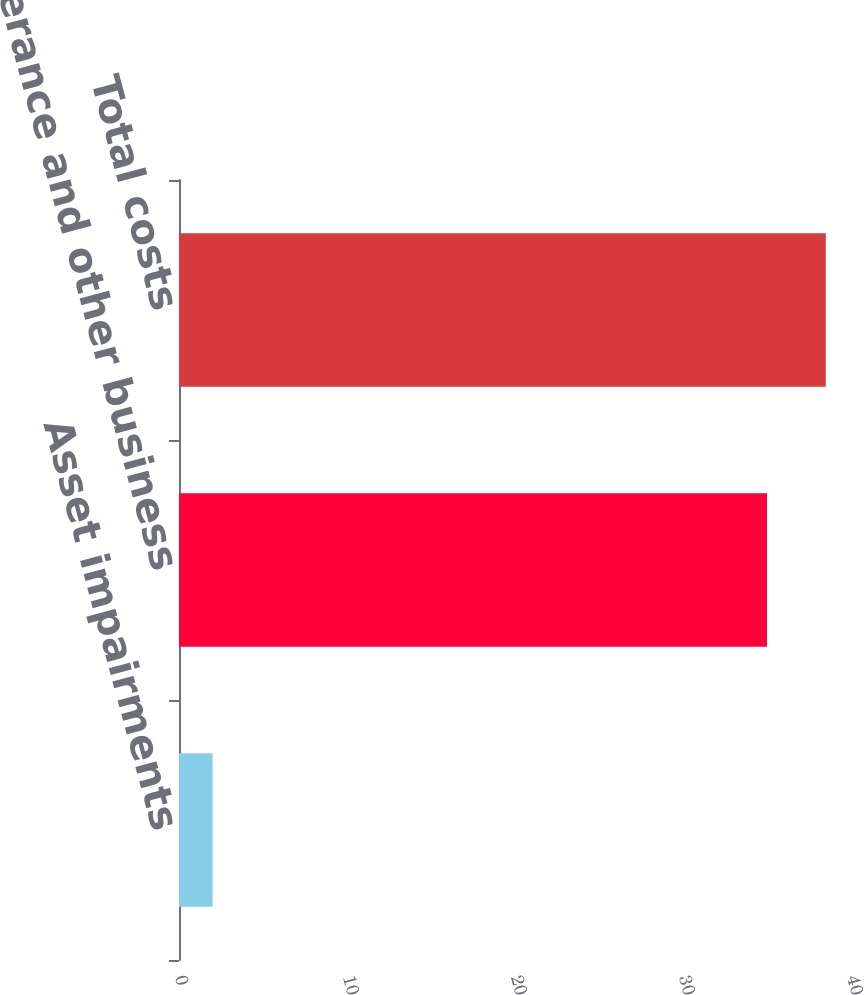Convert chart. <chart><loc_0><loc_0><loc_500><loc_500><bar_chart><fcel>Asset impairments<fcel>Severance and other business<fcel>Total costs<nl><fcel>2<fcel>35<fcel>38.5<nl></chart> 